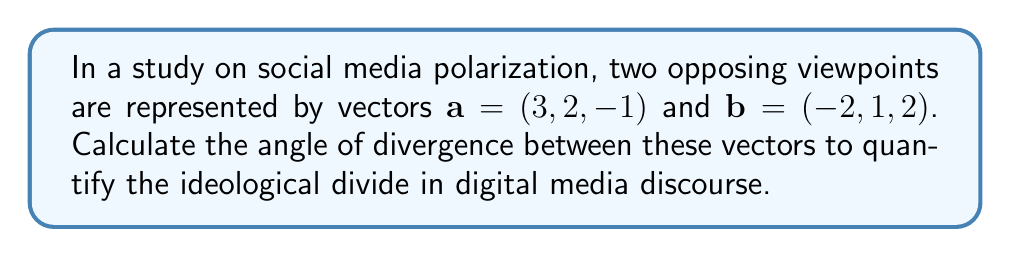Teach me how to tackle this problem. To find the angle between two vectors, we can use the dot product formula:

$$\cos \theta = \frac{\mathbf{a} \cdot \mathbf{b}}{|\mathbf{a}||\mathbf{b}|}$$

Step 1: Calculate the dot product $\mathbf{a} \cdot \mathbf{b}$
$$\mathbf{a} \cdot \mathbf{b} = (3)(-2) + (2)(1) + (-1)(2) = -6 + 2 - 2 = -6$$

Step 2: Calculate the magnitudes of vectors $\mathbf{a}$ and $\mathbf{b}$
$$|\mathbf{a}| = \sqrt{3^2 + 2^2 + (-1)^2} = \sqrt{9 + 4 + 1} = \sqrt{14}$$
$$|\mathbf{b}| = \sqrt{(-2)^2 + 1^2 + 2^2} = \sqrt{4 + 1 + 4} = 3$$

Step 3: Substitute into the formula
$$\cos \theta = \frac{-6}{\sqrt{14} \cdot 3} = \frac{-6}{3\sqrt{14}}$$

Step 4: Take the inverse cosine (arccos) of both sides
$$\theta = \arccos\left(\frac{-6}{3\sqrt{14}}\right)$$

Step 5: Calculate the result (in radians)
$$\theta \approx 2.4980$$

Step 6: Convert to degrees
$$\theta \approx 143.13°$$
Answer: $143.13°$ 